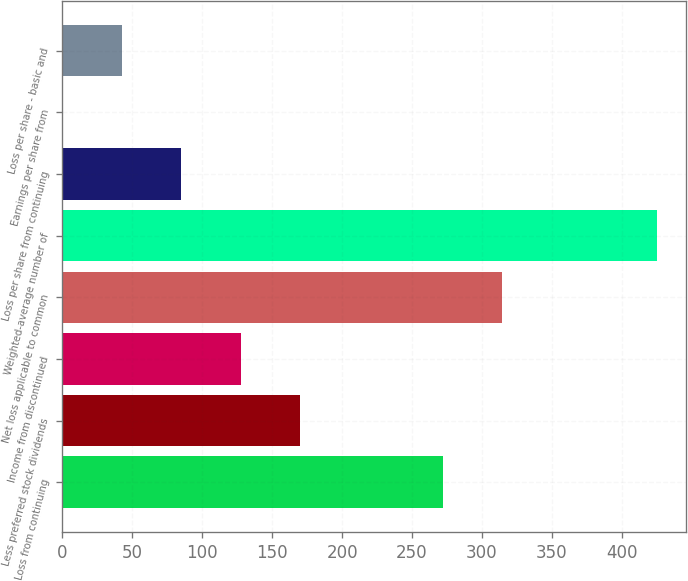Convert chart to OTSL. <chart><loc_0><loc_0><loc_500><loc_500><bar_chart><fcel>Loss from continuing<fcel>Less preferred stock dividends<fcel>Income from discontinued<fcel>Net loss applicable to common<fcel>Weighted-average number of<fcel>Loss per share from continuing<fcel>Earnings per share from<fcel>Loss per share - basic and<nl><fcel>271.9<fcel>169.94<fcel>127.46<fcel>314.38<fcel>424.8<fcel>84.98<fcel>0.02<fcel>42.5<nl></chart> 